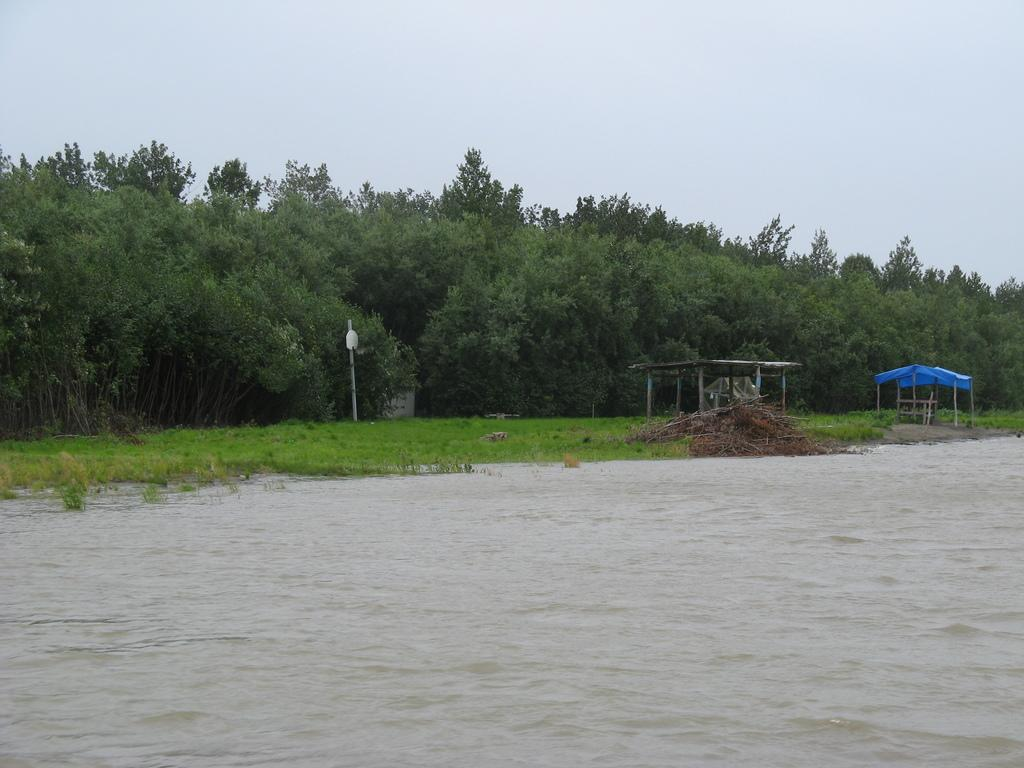What is happening in the image? There is water flowing in the image. What can be seen in the water? There are branches visible in the image. What structures are present in the image? There are shelters in the image. What else can be seen in the image? There is a pole in the image, trees with branches and leaves, and grass visible in the image. Can you see any knots tied on the branches in the image? There are no knots visible on the branches in the image. How many fish can be seen swimming in the water in the image? There are no fish present in the image; it only shows water flowing with branches. 